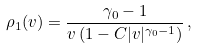Convert formula to latex. <formula><loc_0><loc_0><loc_500><loc_500>\rho _ { 1 } ( v ) = \frac { \gamma _ { 0 } - 1 } { v \left ( 1 - C | v | ^ { \gamma _ { 0 } - 1 } \right ) } \, ,</formula> 